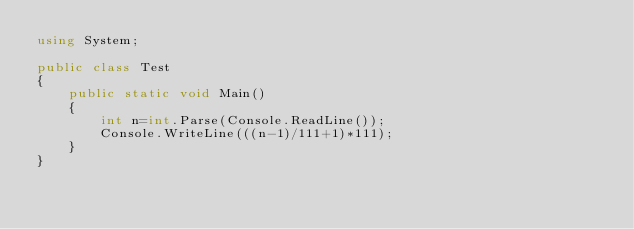Convert code to text. <code><loc_0><loc_0><loc_500><loc_500><_C#_>using System;

public class Test
{
	public static void Main()
	{
		int n=int.Parse(Console.ReadLine());
		Console.WriteLine(((n-1)/111+1)*111);
	}
}</code> 